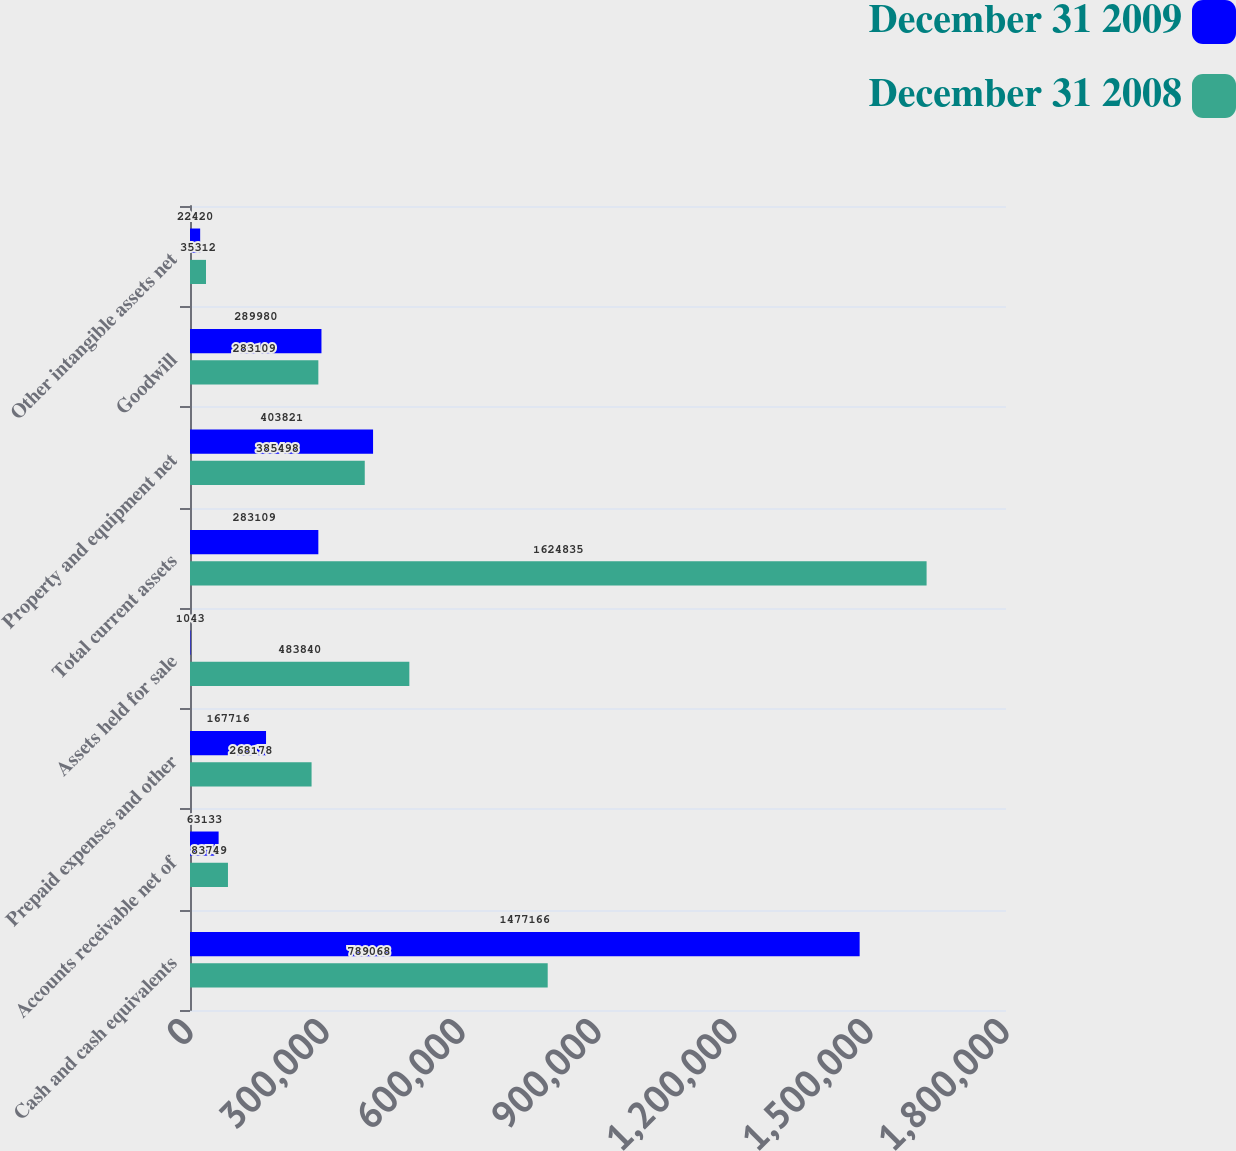Convert chart. <chart><loc_0><loc_0><loc_500><loc_500><stacked_bar_chart><ecel><fcel>Cash and cash equivalents<fcel>Accounts receivable net of<fcel>Prepaid expenses and other<fcel>Assets held for sale<fcel>Total current assets<fcel>Property and equipment net<fcel>Goodwill<fcel>Other intangible assets net<nl><fcel>December 31 2009<fcel>1.47717e+06<fcel>63133<fcel>167716<fcel>1043<fcel>283109<fcel>403821<fcel>289980<fcel>22420<nl><fcel>December 31 2008<fcel>789068<fcel>83749<fcel>268178<fcel>483840<fcel>1.62484e+06<fcel>385498<fcel>283109<fcel>35312<nl></chart> 